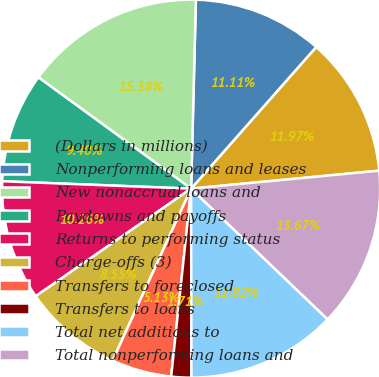<chart> <loc_0><loc_0><loc_500><loc_500><pie_chart><fcel>(Dollars in millions)<fcel>Nonperforming loans and leases<fcel>New nonaccrual loans and<fcel>Paydowns and payoffs<fcel>Returns to performing status<fcel>Charge-offs (3)<fcel>Transfers to foreclosed<fcel>Transfers to loans<fcel>Total net additions to<fcel>Total nonperforming loans and<nl><fcel>11.97%<fcel>11.11%<fcel>15.38%<fcel>9.4%<fcel>10.26%<fcel>8.55%<fcel>5.13%<fcel>1.71%<fcel>12.82%<fcel>13.67%<nl></chart> 